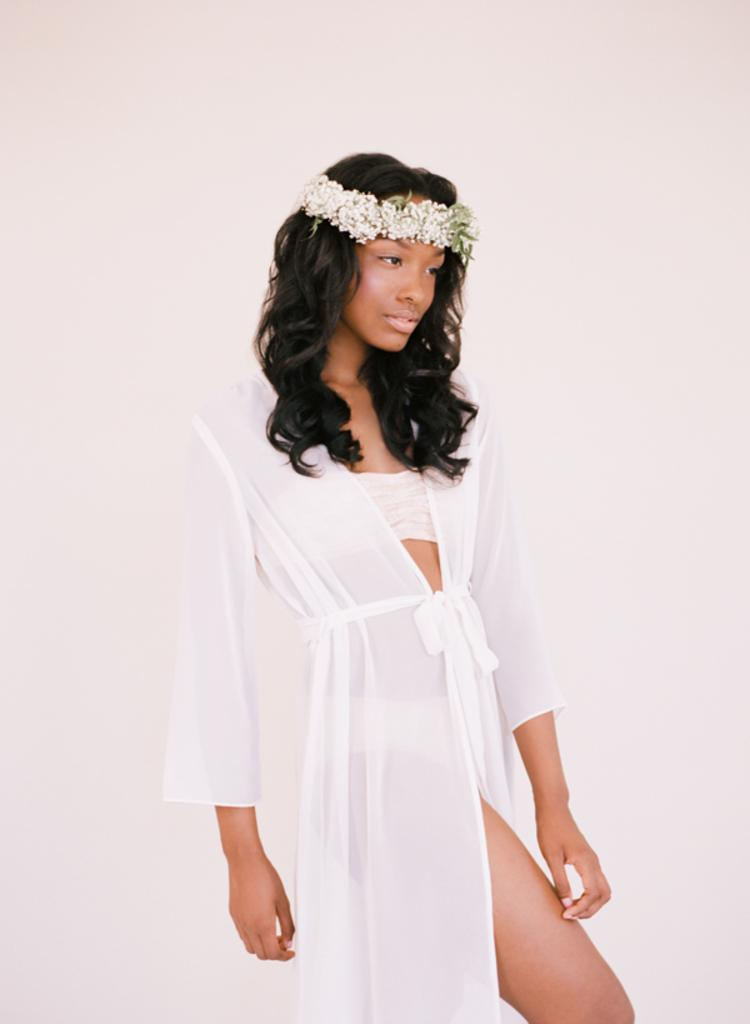What is the color of the wall in the image? The wall in the image is white. Who is present in the image? There is a woman in the image. What is the woman wearing? The woman is wearing a white color dress. What arithmetic problem can be seen solved on the wall? There is no arithmetic problem visible on the wall in the image. 